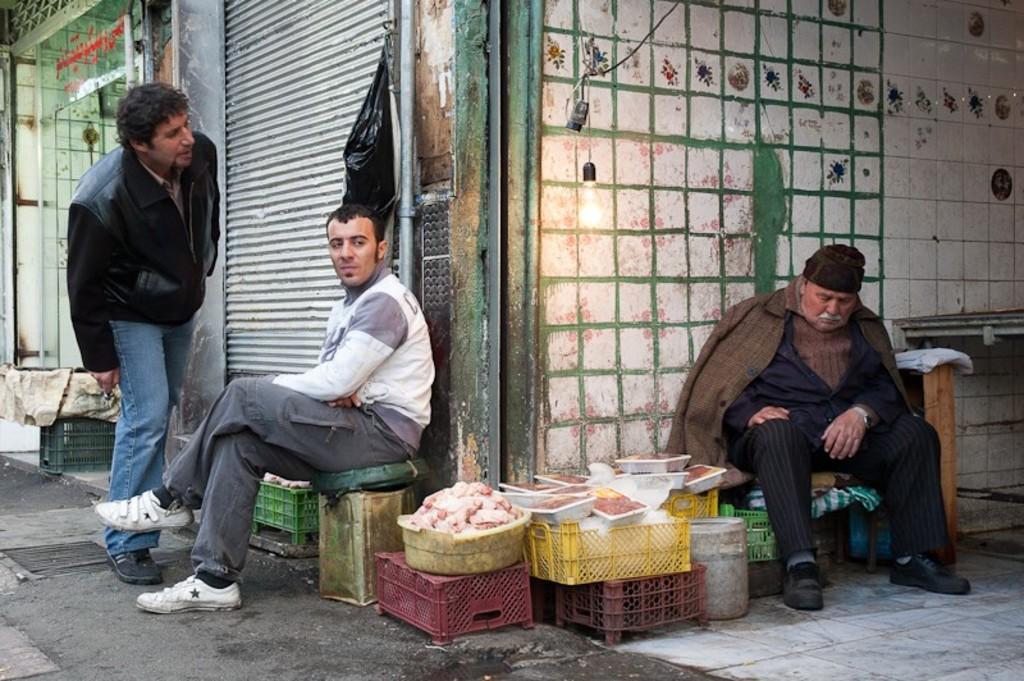Please provide a concise description of this image. In this picture there are three persons. On the left side of the image there is a person sitting on the tin and there is a person standing. There are baskets and there is a shutter and there is a text on the glass door and there is a pipe on the wall. On the right side of the image there is a person sitting and there is a meat in the baskets and there is a table. At the top there is a bulb and wire. 